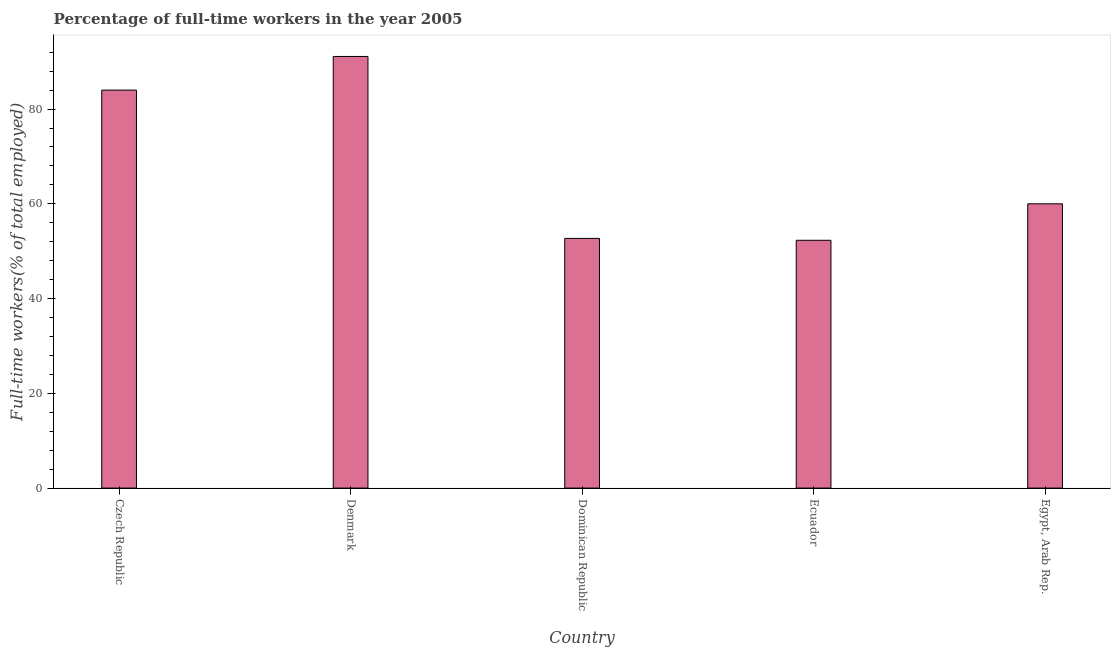Does the graph contain any zero values?
Give a very brief answer. No. Does the graph contain grids?
Ensure brevity in your answer.  No. What is the title of the graph?
Ensure brevity in your answer.  Percentage of full-time workers in the year 2005. What is the label or title of the X-axis?
Provide a short and direct response. Country. What is the label or title of the Y-axis?
Offer a terse response. Full-time workers(% of total employed). What is the percentage of full-time workers in Denmark?
Offer a very short reply. 91.1. Across all countries, what is the maximum percentage of full-time workers?
Provide a succinct answer. 91.1. Across all countries, what is the minimum percentage of full-time workers?
Your response must be concise. 52.3. In which country was the percentage of full-time workers maximum?
Provide a succinct answer. Denmark. In which country was the percentage of full-time workers minimum?
Your answer should be compact. Ecuador. What is the sum of the percentage of full-time workers?
Ensure brevity in your answer.  340.1. What is the difference between the percentage of full-time workers in Czech Republic and Dominican Republic?
Your answer should be very brief. 31.3. What is the average percentage of full-time workers per country?
Keep it short and to the point. 68.02. What is the median percentage of full-time workers?
Provide a short and direct response. 60. What is the ratio of the percentage of full-time workers in Denmark to that in Egypt, Arab Rep.?
Ensure brevity in your answer.  1.52. Is the difference between the percentage of full-time workers in Czech Republic and Egypt, Arab Rep. greater than the difference between any two countries?
Keep it short and to the point. No. What is the difference between the highest and the second highest percentage of full-time workers?
Provide a short and direct response. 7.1. What is the difference between the highest and the lowest percentage of full-time workers?
Offer a terse response. 38.8. In how many countries, is the percentage of full-time workers greater than the average percentage of full-time workers taken over all countries?
Ensure brevity in your answer.  2. How many bars are there?
Your answer should be very brief. 5. Are all the bars in the graph horizontal?
Your answer should be very brief. No. What is the Full-time workers(% of total employed) of Czech Republic?
Keep it short and to the point. 84. What is the Full-time workers(% of total employed) of Denmark?
Your answer should be compact. 91.1. What is the Full-time workers(% of total employed) in Dominican Republic?
Your answer should be compact. 52.7. What is the Full-time workers(% of total employed) of Ecuador?
Make the answer very short. 52.3. What is the difference between the Full-time workers(% of total employed) in Czech Republic and Denmark?
Keep it short and to the point. -7.1. What is the difference between the Full-time workers(% of total employed) in Czech Republic and Dominican Republic?
Your response must be concise. 31.3. What is the difference between the Full-time workers(% of total employed) in Czech Republic and Ecuador?
Give a very brief answer. 31.7. What is the difference between the Full-time workers(% of total employed) in Denmark and Dominican Republic?
Provide a succinct answer. 38.4. What is the difference between the Full-time workers(% of total employed) in Denmark and Ecuador?
Your answer should be compact. 38.8. What is the difference between the Full-time workers(% of total employed) in Denmark and Egypt, Arab Rep.?
Give a very brief answer. 31.1. What is the difference between the Full-time workers(% of total employed) in Dominican Republic and Egypt, Arab Rep.?
Offer a very short reply. -7.3. What is the difference between the Full-time workers(% of total employed) in Ecuador and Egypt, Arab Rep.?
Provide a succinct answer. -7.7. What is the ratio of the Full-time workers(% of total employed) in Czech Republic to that in Denmark?
Offer a terse response. 0.92. What is the ratio of the Full-time workers(% of total employed) in Czech Republic to that in Dominican Republic?
Your answer should be very brief. 1.59. What is the ratio of the Full-time workers(% of total employed) in Czech Republic to that in Ecuador?
Keep it short and to the point. 1.61. What is the ratio of the Full-time workers(% of total employed) in Denmark to that in Dominican Republic?
Offer a terse response. 1.73. What is the ratio of the Full-time workers(% of total employed) in Denmark to that in Ecuador?
Provide a short and direct response. 1.74. What is the ratio of the Full-time workers(% of total employed) in Denmark to that in Egypt, Arab Rep.?
Provide a short and direct response. 1.52. What is the ratio of the Full-time workers(% of total employed) in Dominican Republic to that in Egypt, Arab Rep.?
Keep it short and to the point. 0.88. What is the ratio of the Full-time workers(% of total employed) in Ecuador to that in Egypt, Arab Rep.?
Provide a short and direct response. 0.87. 